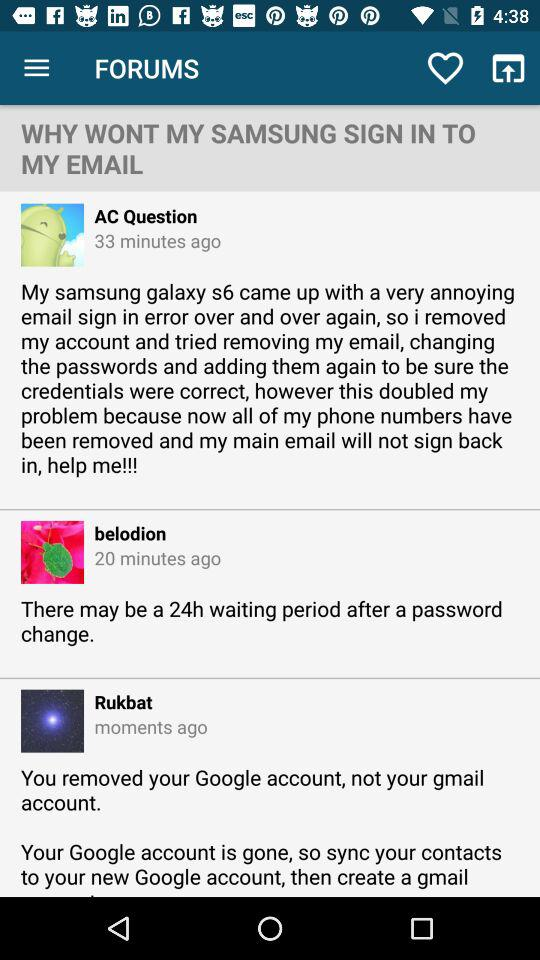How many minutes ago did "AC Question" post the comment? "AC Question" did post the comment 33 minutes ago. 